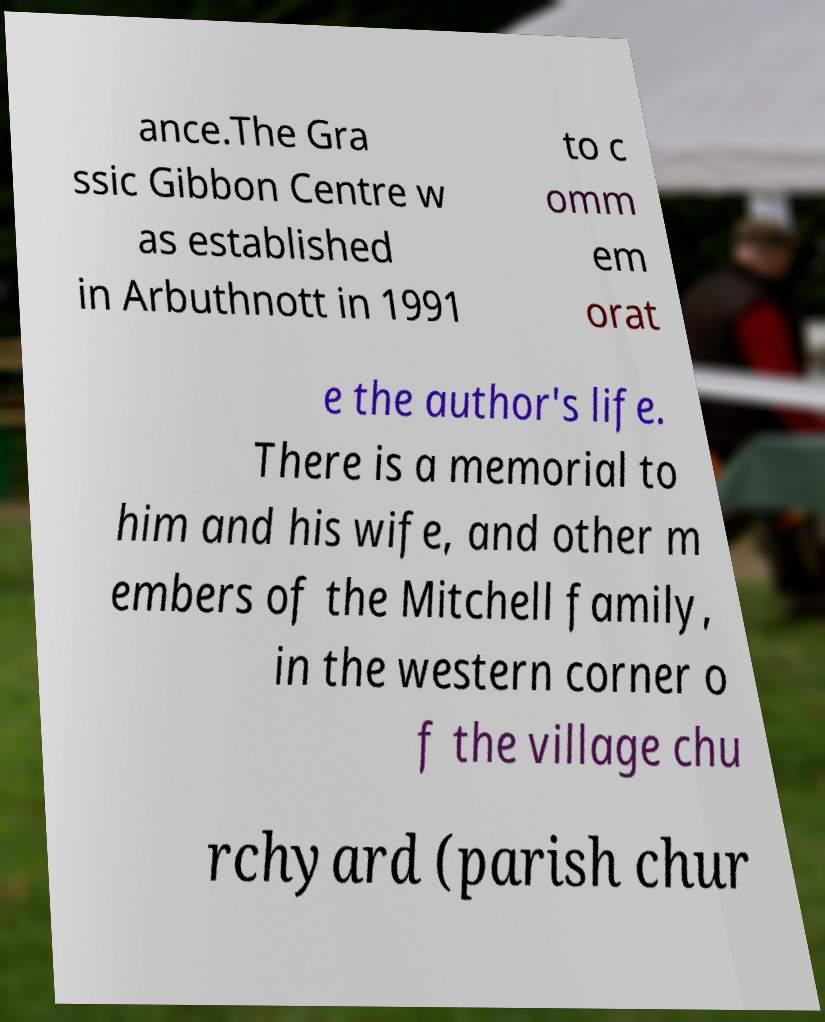Could you assist in decoding the text presented in this image and type it out clearly? ance.The Gra ssic Gibbon Centre w as established in Arbuthnott in 1991 to c omm em orat e the author's life. There is a memorial to him and his wife, and other m embers of the Mitchell family, in the western corner o f the village chu rchyard (parish chur 